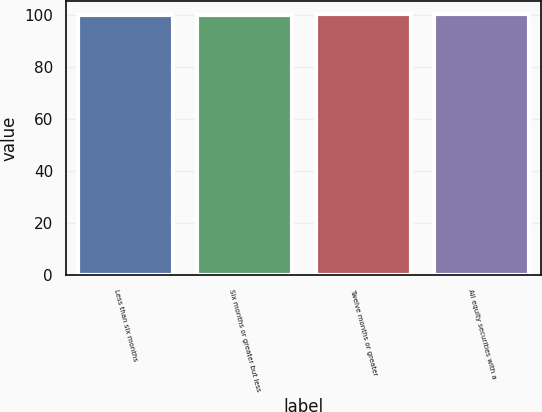Convert chart. <chart><loc_0><loc_0><loc_500><loc_500><bar_chart><fcel>Less than six months<fcel>Six months or greater but less<fcel>Twelve months or greater<fcel>All equity securities with a<nl><fcel>100<fcel>100.1<fcel>100.2<fcel>100.3<nl></chart> 